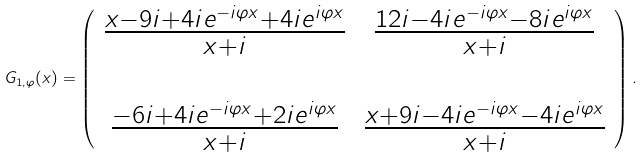Convert formula to latex. <formula><loc_0><loc_0><loc_500><loc_500>G _ { 1 , \varphi } ( x ) = \left ( \begin{array} { c c } \frac { x - 9 i + 4 i e ^ { - i \varphi x } + 4 i e ^ { i \varphi x } } { x + i } & \frac { 1 2 i - 4 i e ^ { - i \varphi x } - 8 i e ^ { i \varphi x } } { x + i } \\ & \\ \frac { - 6 i + 4 i e ^ { - i \varphi x } + 2 i e ^ { i \varphi x } } { x + i } & \frac { x + 9 i - 4 i e ^ { - i \varphi x } - 4 i e ^ { i \varphi x } } { x + i } \end{array} \right ) .</formula> 